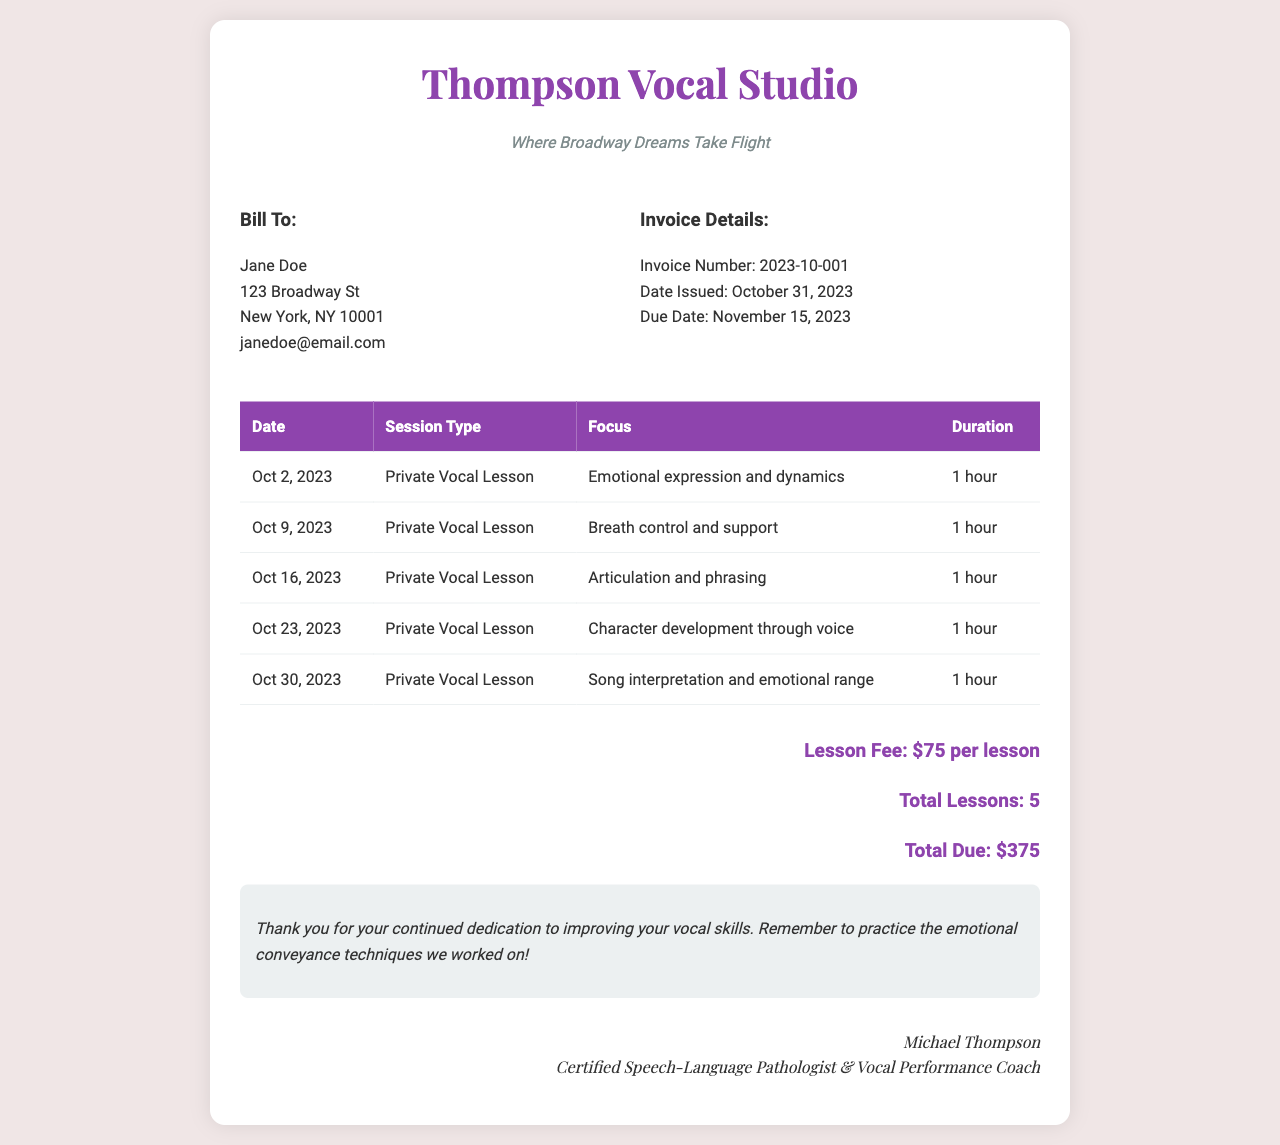What is the total due for the lessons? The total due is found in the payment summary section of the invoice, which states the amount owed.
Answer: $375 Who is the vocal coach? This information is located at the bottom of the document where the signature is displayed.
Answer: Michael Thompson What is the due date for the invoice? The due date can be found in the invoice details section, indicating when the payment is required.
Answer: November 15, 2023 How many private vocal lessons were there in October 2023? The total number of lessons is derived from counting the entries in the session table.
Answer: 5 What was the focus of the lesson on October 16, 2023? This detail is included in the session table, specifying what was worked on during that particular session.
Answer: Articulation and phrasing What is the lesson fee per session? The fee for each lesson is provided in the payment summary of the document.
Answer: $75 What type of lesson was provided on October 2, 2023? The type of the lesson is listed in the session table, identifying the nature of the training.
Answer: Private Vocal Lesson What was the focus of the last lesson? The focus of the last lesson is indicated in the table, revealing what was covered in that session.
Answer: Song interpretation and emotional range 